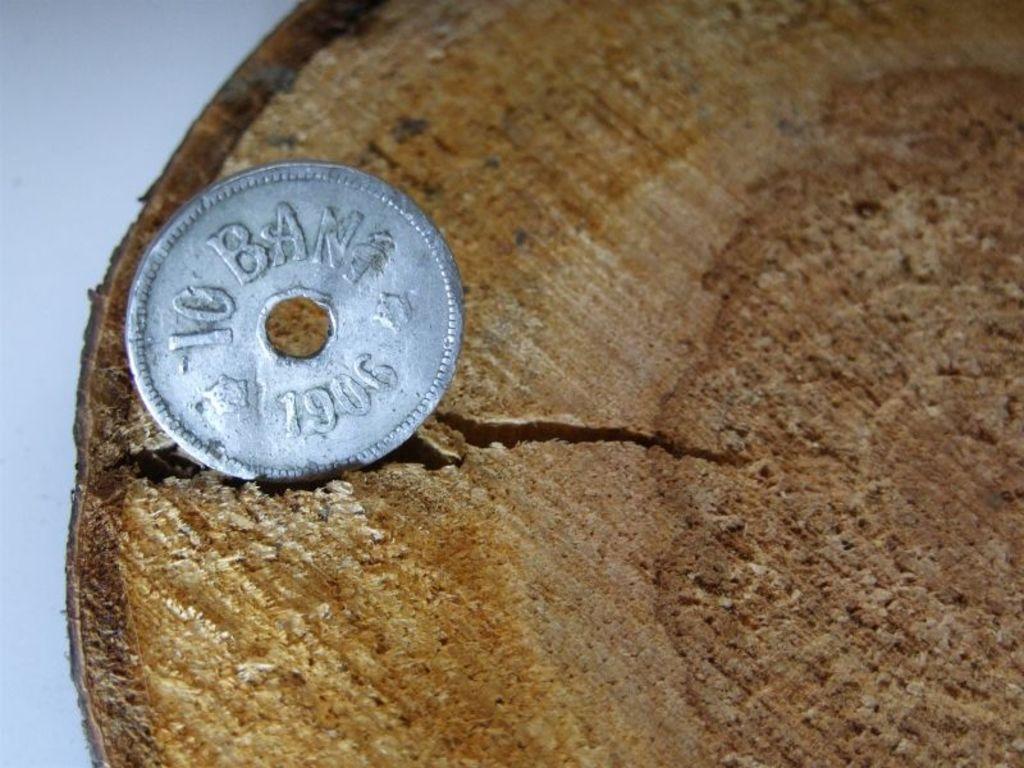What year was this coin made?
Provide a succinct answer. 1906. 